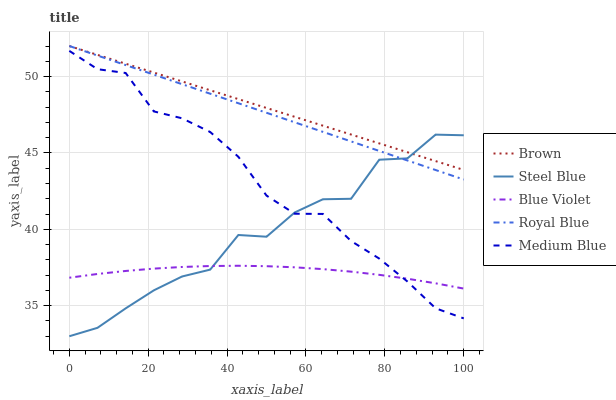Does Blue Violet have the minimum area under the curve?
Answer yes or no. Yes. Does Brown have the maximum area under the curve?
Answer yes or no. Yes. Does Medium Blue have the minimum area under the curve?
Answer yes or no. No. Does Medium Blue have the maximum area under the curve?
Answer yes or no. No. Is Brown the smoothest?
Answer yes or no. Yes. Is Steel Blue the roughest?
Answer yes or no. Yes. Is Medium Blue the smoothest?
Answer yes or no. No. Is Medium Blue the roughest?
Answer yes or no. No. Does Medium Blue have the lowest value?
Answer yes or no. No. Does Medium Blue have the highest value?
Answer yes or no. No. Is Medium Blue less than Brown?
Answer yes or no. Yes. Is Brown greater than Medium Blue?
Answer yes or no. Yes. Does Medium Blue intersect Brown?
Answer yes or no. No. 